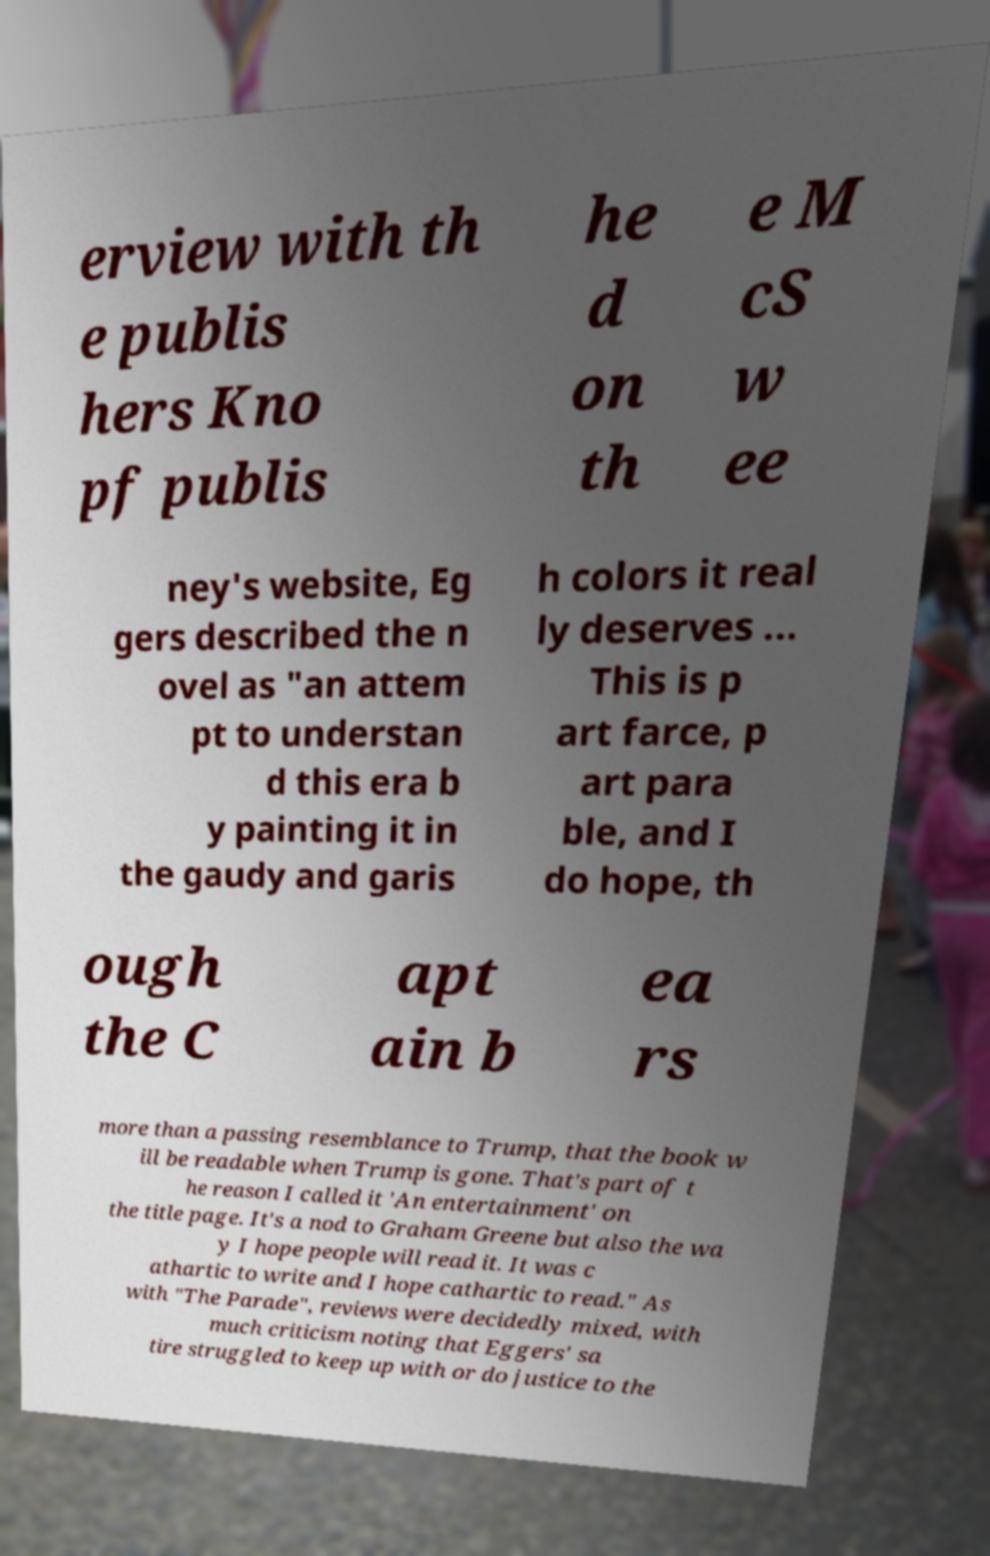There's text embedded in this image that I need extracted. Can you transcribe it verbatim? erview with th e publis hers Kno pf publis he d on th e M cS w ee ney's website, Eg gers described the n ovel as "an attem pt to understan d this era b y painting it in the gaudy and garis h colors it real ly deserves ... This is p art farce, p art para ble, and I do hope, th ough the C apt ain b ea rs more than a passing resemblance to Trump, that the book w ill be readable when Trump is gone. That's part of t he reason I called it 'An entertainment' on the title page. It's a nod to Graham Greene but also the wa y I hope people will read it. It was c athartic to write and I hope cathartic to read." As with "The Parade", reviews were decidedly mixed, with much criticism noting that Eggers' sa tire struggled to keep up with or do justice to the 